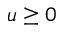Convert formula to latex. <formula><loc_0><loc_0><loc_500><loc_500>u \geq 0</formula> 